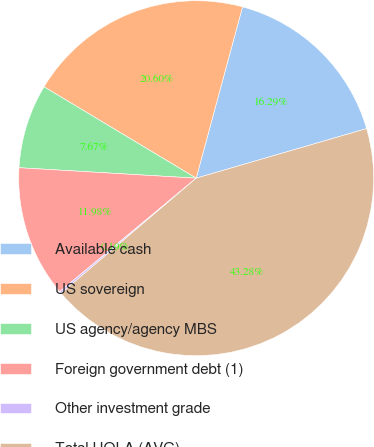Convert chart to OTSL. <chart><loc_0><loc_0><loc_500><loc_500><pie_chart><fcel>Available cash<fcel>US sovereign<fcel>US agency/agency MBS<fcel>Foreign government debt (1)<fcel>Other investment grade<fcel>Total HQLA (AVG)<nl><fcel>16.29%<fcel>20.6%<fcel>7.67%<fcel>11.98%<fcel>0.19%<fcel>43.28%<nl></chart> 